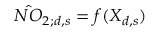<formula> <loc_0><loc_0><loc_500><loc_500>\hat { N O } _ { 2 ; d , s } = f ( X _ { d , s } )</formula> 